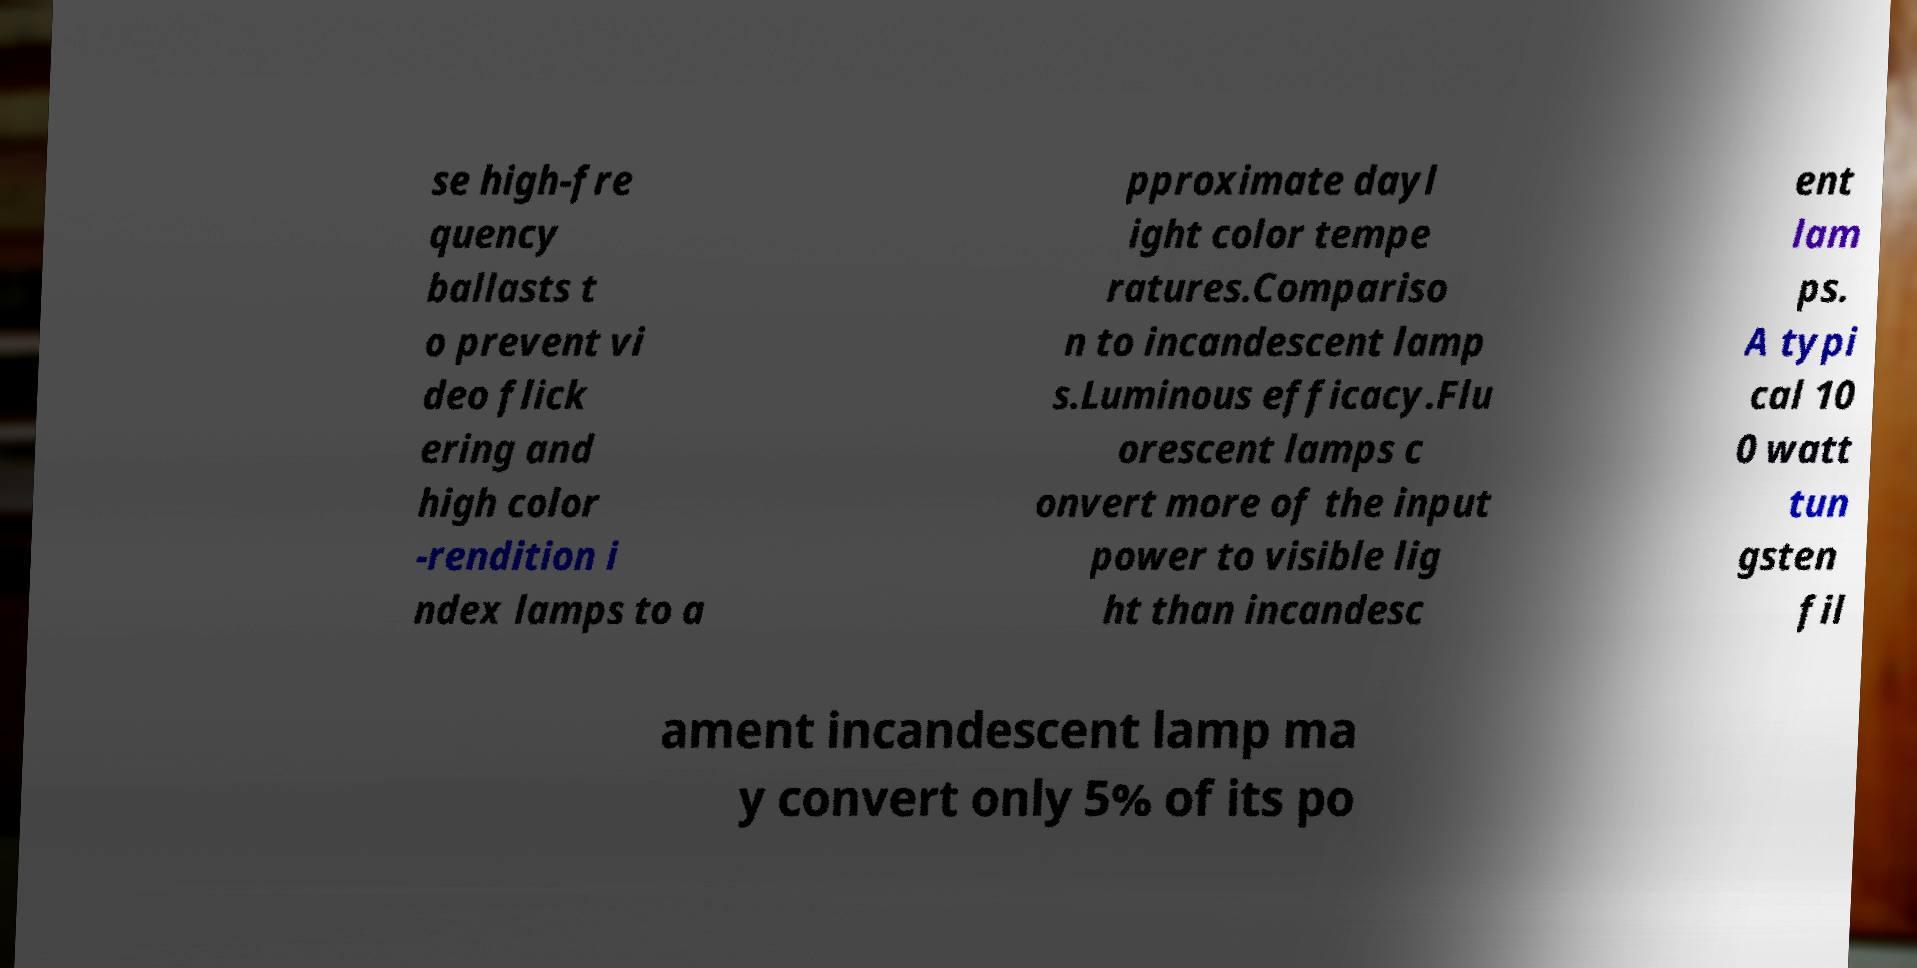I need the written content from this picture converted into text. Can you do that? se high-fre quency ballasts t o prevent vi deo flick ering and high color -rendition i ndex lamps to a pproximate dayl ight color tempe ratures.Compariso n to incandescent lamp s.Luminous efficacy.Flu orescent lamps c onvert more of the input power to visible lig ht than incandesc ent lam ps. A typi cal 10 0 watt tun gsten fil ament incandescent lamp ma y convert only 5% of its po 